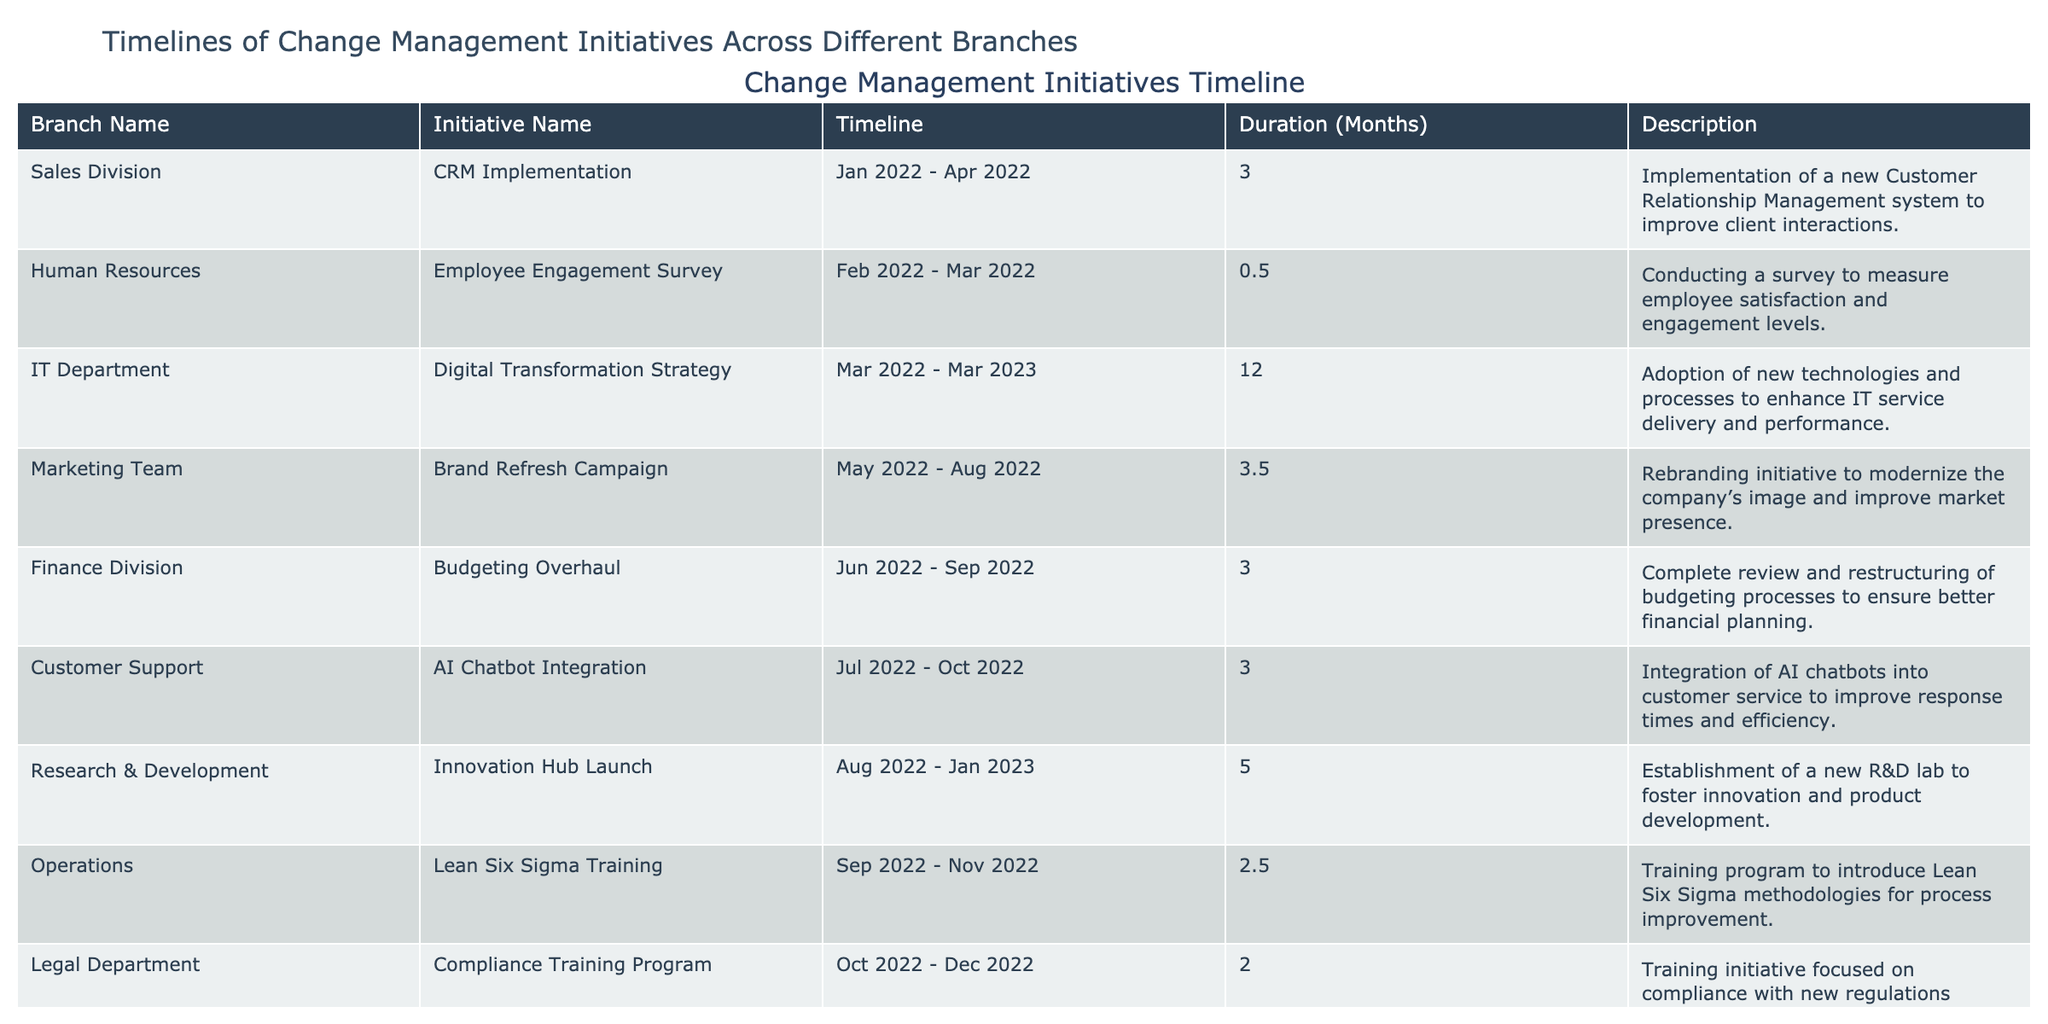What is the duration of the CRM Implementation initiative? The duration of the CRM Implementation initiative listed under the Sales Division is 3 months, as found in the corresponding cell of the table.
Answer: 3 months Which branch is undertaking the Digital Transformation Strategy? The branch undertaking the Digital Transformation Strategy is the IT Department, as specified in the first column of the table.
Answer: IT Department How many initiatives have durations longer than 3 months? The initiatives with durations longer than 3 months are the Digital Transformation Strategy (12 months) and the Innovation Hub Launch (5 months). Therefore, there are 2 initiatives longer than 3 months.
Answer: 2 Is there any initiative in the Legal Department? Yes, there is an initiative in the Legal Department named Compliance Training Program, indicated in the table.
Answer: Yes What are the start and end dates for the Brand Refresh Campaign? The Brand Refresh Campaign starts on May 1, 2022, and ends on August 15, 2022, according to the timeline specified in the table.
Answer: May 1, 2022 - August 15, 2022 How many months did the Compliance Training Program last? The Compliance Training Program lasts for 2 months, as indicated in the Duration (Months) column.
Answer: 2 months What is the average duration of all the initiatives listed? The total duration is calculated by summing the durations: 3 + 0.5 + 12 + 3.5 + 3 + 3 + 5 + 2.5 + 2 + 3 = 33.5 months. There are 10 initiatives, so the average duration is 33.5 / 10 = 3.35 months.
Answer: 3.35 months Which initiative had the shortest duration, and what was its duration? The initiative with the shortest duration is the Employee Engagement Survey, which lasted for 0.5 months, as noted in the Duration (Months) column.
Answer: Employee Engagement Survey, 0.5 months How many initiatives started after June 1, 2022? The initiatives that started after June 1, 2022, are the AI Chatbot Integration, Innovation Hub Launch, Lean Six Sigma Training, and Quality Assurance Revamp. This totals to 4 initiatives.
Answer: 4 Which branch has the longest duration for its change management initiative? The IT Department has the longest duration for its change management initiative, the Digital Transformation Strategy, lasting 12 months, as indicated in the table.
Answer: IT Department (12 months) 